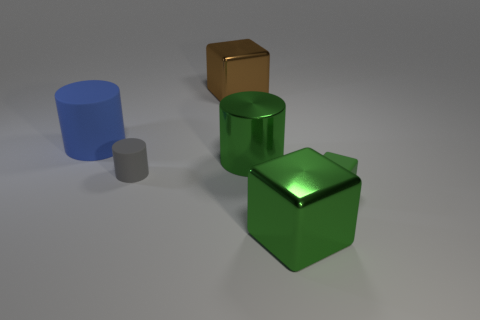Add 1 tiny yellow things. How many objects exist? 7 Subtract all large blue cylinders. How many cylinders are left? 2 Subtract all gray cylinders. How many cylinders are left? 2 Subtract 3 cubes. How many cubes are left? 0 Subtract 0 purple spheres. How many objects are left? 6 Subtract all green blocks. Subtract all cyan cylinders. How many blocks are left? 1 Subtract all gray cylinders. How many red blocks are left? 0 Subtract all large rubber cylinders. Subtract all big gray metal cylinders. How many objects are left? 5 Add 2 tiny gray rubber cylinders. How many tiny gray rubber cylinders are left? 3 Add 1 small green objects. How many small green objects exist? 2 